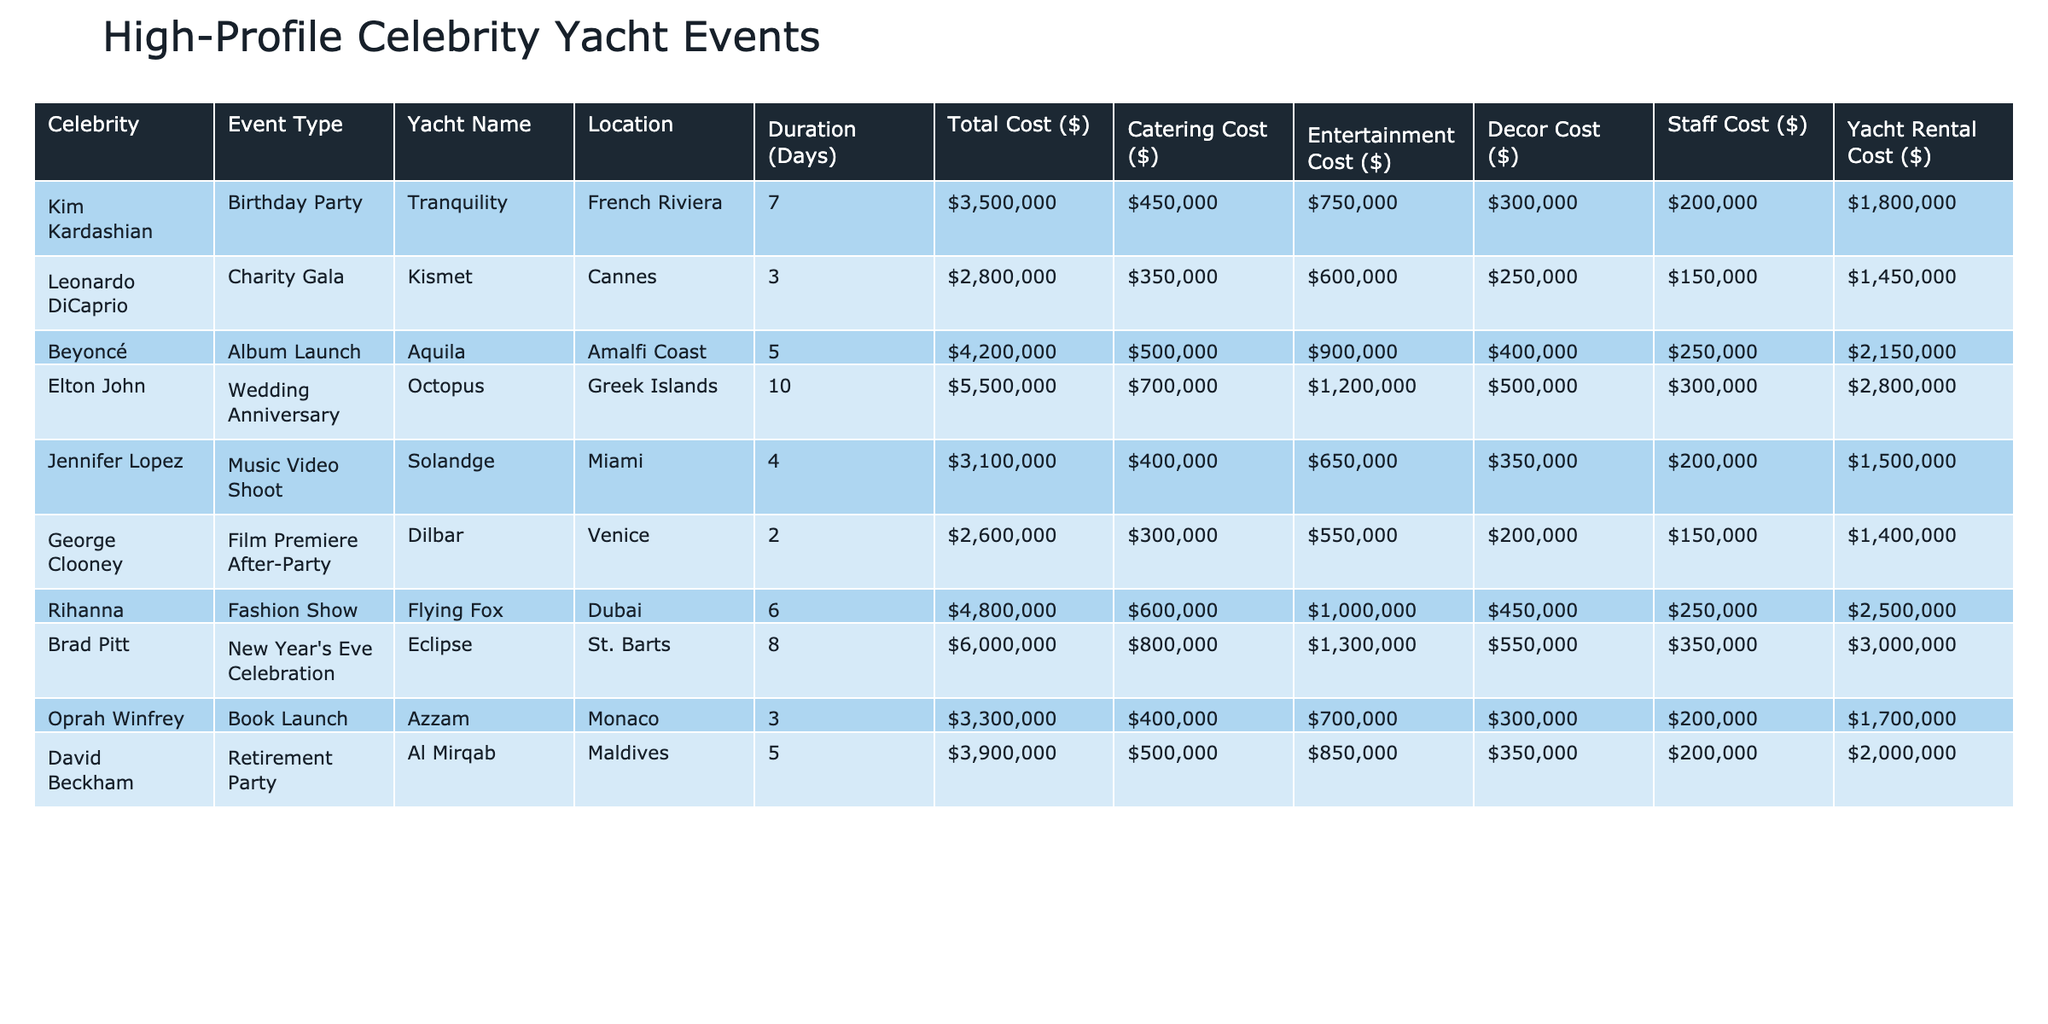What is the total cost of Kim Kardashian's birthday party? The table shows that the total cost for Kim Kardashian's birthday party is listed as $3,500,000.
Answer: $3,500,000 Which event had the highest catering cost? Comparing the catering costs in the table, Elton John's wedding anniversary has the highest catering cost of $700,000.
Answer: $700,000 How many days did Leonardo DiCaprio's charity gala last? The table indicates that Leonardo DiCaprio's charity gala lasted for 3 days.
Answer: 3 days What is the average total cost of all the events listed? To find the average, sum the total costs of all events: $3,500,000 + $2,800,000 + $4,200,000 + $5,500,000 + $3,100,000 + $2,600,000 + $4,800,000 + $6,000,000 + $3,300,000 + $3,900,000 = $38,700,000; divide by 10 (the number of events): $38,700,000 / 10 = $3,870,000.
Answer: $3,870,000 Is the total cost of Rihanna's fashion show greater than the total cost of George Clooney's film premiere after-party? Rihanna's fashion show cost $4,800,000 and George Clooney's after-party cost $2,600,000. Since $4,800,000 > $2,600,000, the statement is true.
Answer: Yes If we combine the yacht rental costs of Beyoncé's album launch and Brad Pitt's New Year's Eve celebration, what would the total be? Beyoncé's yacht rental cost is $2,150,000, and Brad Pitt's is $3,000,000. Combining these gives $2,150,000 + $3,000,000 = $5,150,000.
Answer: $5,150,000 What percentage of the total cost of Jennifer Lopez's music video shoot is attributed to entertainment costs? The total cost for Jennifer Lopez's music video shoot is $3,100,000, with entertainment costs of $650,000. Calculate the percentage: ($650,000 / $3,100,000) * 100 = 20.97%.
Answer: 20.97% Which event type had the longest duration and what was its total cost? The longest duration is for Elton John's wedding anniversary at 10 days, and its total cost is $5,500,000.
Answer: 10 days, $5,500,000 What is the total cost difference between David Beckham's retirement party and Kim Kardashian's birthday party? David Beckham’s total cost is $3,900,000, while Kim Kardashian’s is $3,500,000. The difference is $3,900,000 - $3,500,000 = $400,000.
Answer: $400,000 How many events took place in the French Riviera, and what was the total associated cost? Only one event took place in the French Riviera, which is Kim Kardashian's birthday party, with a total cost of $3,500,000.
Answer: 1 event, $3,500,000 Is Oprah Winfrey's book launch event higher in total cost compared to George Clooney's after-party? Oprah Winfrey’s event cost is $3,300,000, and George Clooney’s event is $2,600,000. Since $3,300,000 > $2,600,000, the answer is yes.
Answer: Yes 